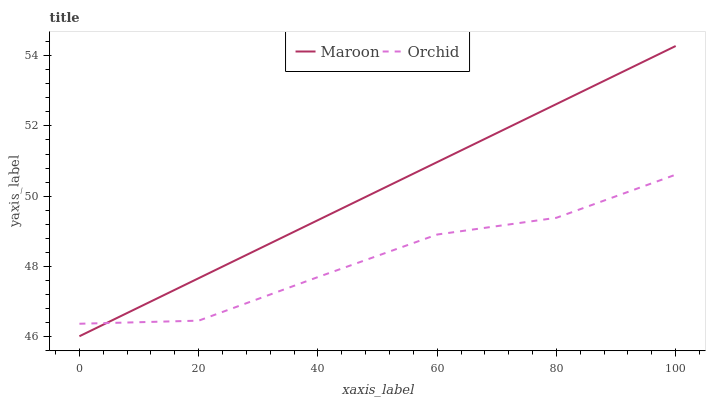Does Orchid have the maximum area under the curve?
Answer yes or no. No. Is Orchid the smoothest?
Answer yes or no. No. Does Orchid have the lowest value?
Answer yes or no. No. Does Orchid have the highest value?
Answer yes or no. No. 